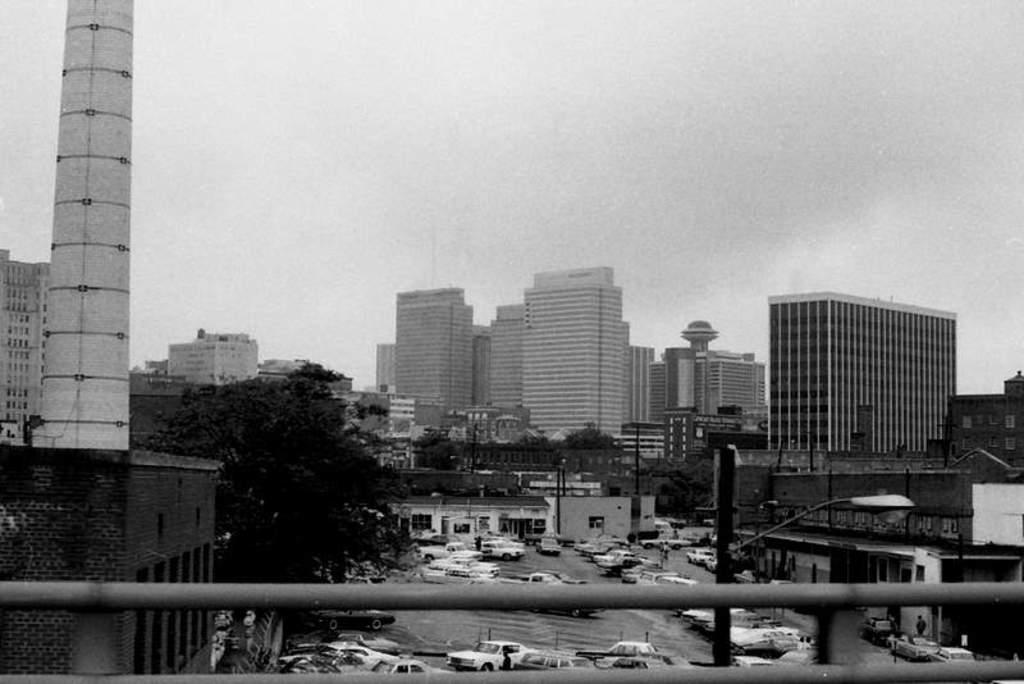What type of objects can be seen in the image that are made of metal? There are iron rods in the image. What is happening on the road in the image? There are vehicles on the road in the image. What are the tall, slender objects in the image? There are poles in the image. What can be seen attached to the poles in the image? There are lights in the image. What type of structures are visible in the image? There are buildings in the image. What type of vegetation is present in the image? There are trees in the image. What part of the natural environment is visible in the image? The sky is visible in the image. What type of joke is the father telling in the image? There is no father or joke present in the image. Can you describe the type of fly that is buzzing around the buildings in the image? There are no flies present in the image; it only features iron rods, vehicles, poles, lights, buildings, trees, and the sky. 